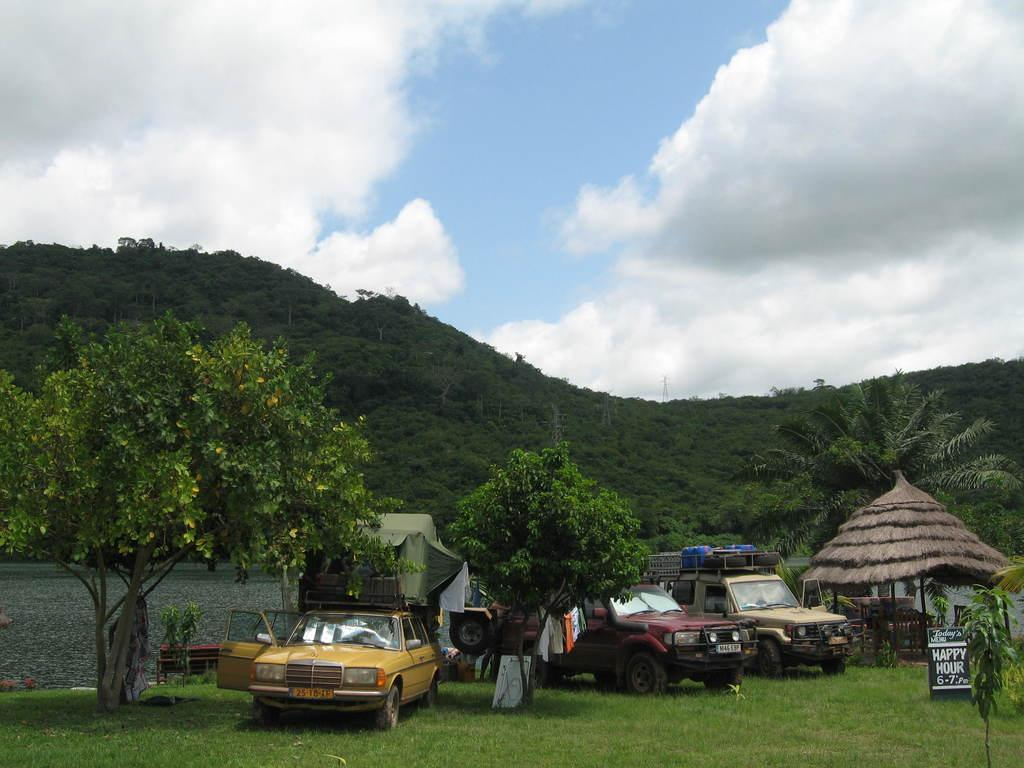What types of objects can be seen in the image? There are vehicles, boards, and electric steel towers in the image. What can be found on the grass in the image? There are trees on the grass in the image. What is located behind the vehicles in the image? There is a wall behind the vehicles, and houses are located behind the wall. What geographical feature is visible in the image? There is a hill visible in the image. What part of the natural environment is visible in the image? The sky is visible in the image. What type of space-related object can be seen in the image? There are no space-related objects present in the image. What sound can be heard coming from the vehicles in the image? The image is silent, so no sounds can be heard. 